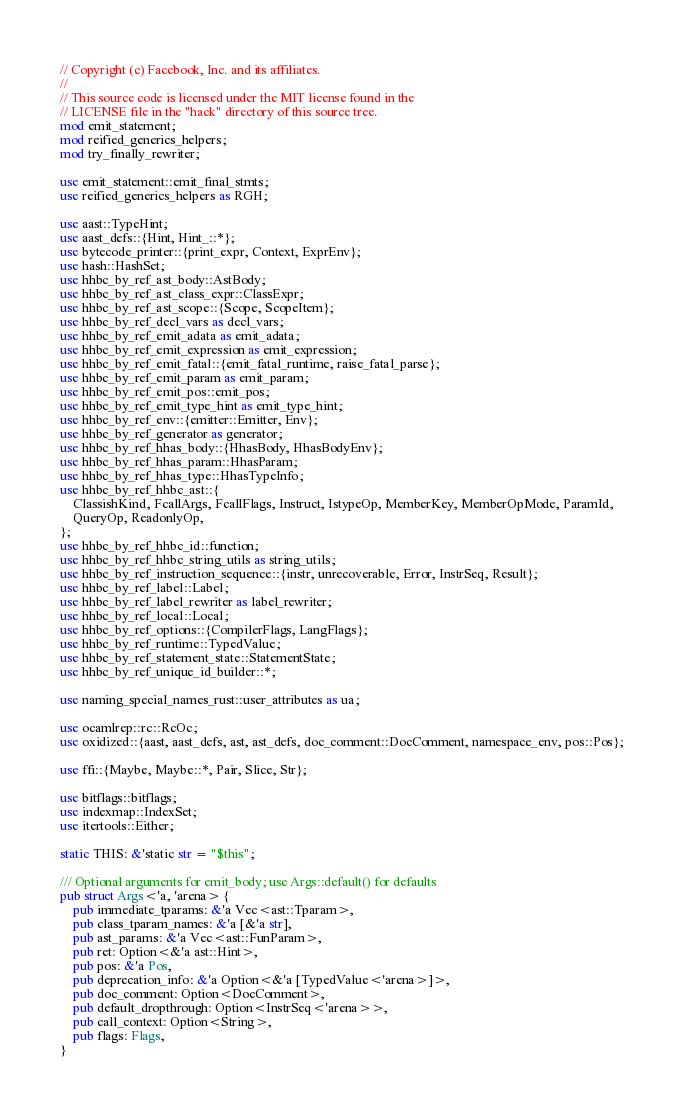<code> <loc_0><loc_0><loc_500><loc_500><_Rust_>// Copyright (c) Facebook, Inc. and its affiliates.
//
// This source code is licensed under the MIT license found in the
// LICENSE file in the "hack" directory of this source tree.
mod emit_statement;
mod reified_generics_helpers;
mod try_finally_rewriter;

use emit_statement::emit_final_stmts;
use reified_generics_helpers as RGH;

use aast::TypeHint;
use aast_defs::{Hint, Hint_::*};
use bytecode_printer::{print_expr, Context, ExprEnv};
use hash::HashSet;
use hhbc_by_ref_ast_body::AstBody;
use hhbc_by_ref_ast_class_expr::ClassExpr;
use hhbc_by_ref_ast_scope::{Scope, ScopeItem};
use hhbc_by_ref_decl_vars as decl_vars;
use hhbc_by_ref_emit_adata as emit_adata;
use hhbc_by_ref_emit_expression as emit_expression;
use hhbc_by_ref_emit_fatal::{emit_fatal_runtime, raise_fatal_parse};
use hhbc_by_ref_emit_param as emit_param;
use hhbc_by_ref_emit_pos::emit_pos;
use hhbc_by_ref_emit_type_hint as emit_type_hint;
use hhbc_by_ref_env::{emitter::Emitter, Env};
use hhbc_by_ref_generator as generator;
use hhbc_by_ref_hhas_body::{HhasBody, HhasBodyEnv};
use hhbc_by_ref_hhas_param::HhasParam;
use hhbc_by_ref_hhas_type::HhasTypeInfo;
use hhbc_by_ref_hhbc_ast::{
    ClassishKind, FcallArgs, FcallFlags, Instruct, IstypeOp, MemberKey, MemberOpMode, ParamId,
    QueryOp, ReadonlyOp,
};
use hhbc_by_ref_hhbc_id::function;
use hhbc_by_ref_hhbc_string_utils as string_utils;
use hhbc_by_ref_instruction_sequence::{instr, unrecoverable, Error, InstrSeq, Result};
use hhbc_by_ref_label::Label;
use hhbc_by_ref_label_rewriter as label_rewriter;
use hhbc_by_ref_local::Local;
use hhbc_by_ref_options::{CompilerFlags, LangFlags};
use hhbc_by_ref_runtime::TypedValue;
use hhbc_by_ref_statement_state::StatementState;
use hhbc_by_ref_unique_id_builder::*;

use naming_special_names_rust::user_attributes as ua;

use ocamlrep::rc::RcOc;
use oxidized::{aast, aast_defs, ast, ast_defs, doc_comment::DocComment, namespace_env, pos::Pos};

use ffi::{Maybe, Maybe::*, Pair, Slice, Str};

use bitflags::bitflags;
use indexmap::IndexSet;
use itertools::Either;

static THIS: &'static str = "$this";

/// Optional arguments for emit_body; use Args::default() for defaults
pub struct Args<'a, 'arena> {
    pub immediate_tparams: &'a Vec<ast::Tparam>,
    pub class_tparam_names: &'a [&'a str],
    pub ast_params: &'a Vec<ast::FunParam>,
    pub ret: Option<&'a ast::Hint>,
    pub pos: &'a Pos,
    pub deprecation_info: &'a Option<&'a [TypedValue<'arena>]>,
    pub doc_comment: Option<DocComment>,
    pub default_dropthrough: Option<InstrSeq<'arena>>,
    pub call_context: Option<String>,
    pub flags: Flags,
}
</code> 